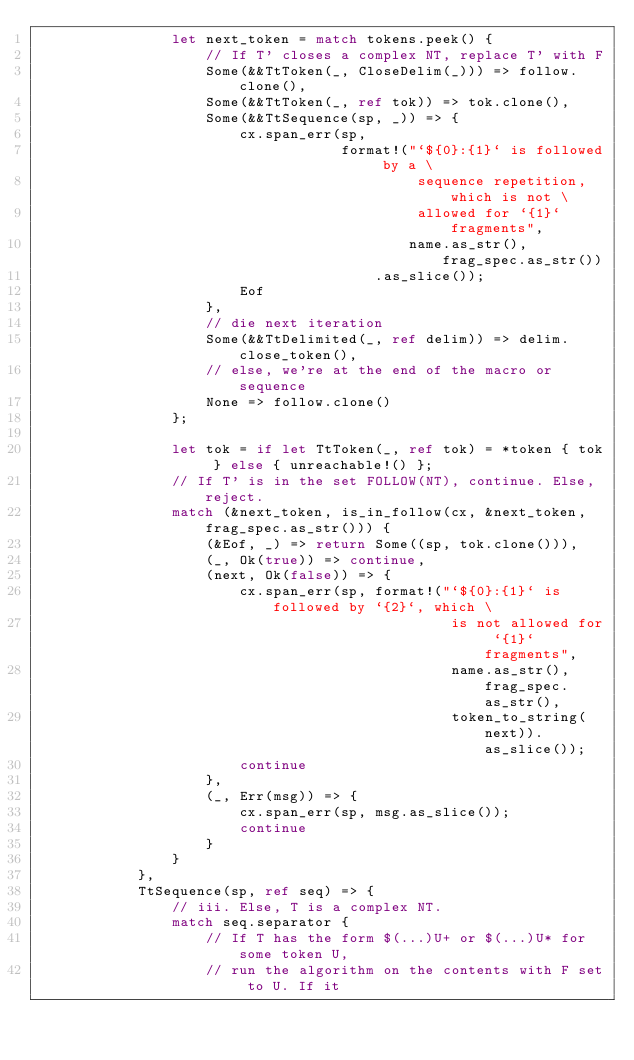Convert code to text. <code><loc_0><loc_0><loc_500><loc_500><_Rust_>                let next_token = match tokens.peek() {
                    // If T' closes a complex NT, replace T' with F
                    Some(&&TtToken(_, CloseDelim(_))) => follow.clone(),
                    Some(&&TtToken(_, ref tok)) => tok.clone(),
                    Some(&&TtSequence(sp, _)) => {
                        cx.span_err(sp,
                                    format!("`${0}:{1}` is followed by a \
                                             sequence repetition, which is not \
                                             allowed for `{1}` fragments",
                                            name.as_str(), frag_spec.as_str())
                                        .as_slice());
                        Eof
                    },
                    // die next iteration
                    Some(&&TtDelimited(_, ref delim)) => delim.close_token(),
                    // else, we're at the end of the macro or sequence
                    None => follow.clone()
                };

                let tok = if let TtToken(_, ref tok) = *token { tok } else { unreachable!() };
                // If T' is in the set FOLLOW(NT), continue. Else, reject.
                match (&next_token, is_in_follow(cx, &next_token, frag_spec.as_str())) {
                    (&Eof, _) => return Some((sp, tok.clone())),
                    (_, Ok(true)) => continue,
                    (next, Ok(false)) => {
                        cx.span_err(sp, format!("`${0}:{1}` is followed by `{2}`, which \
                                                 is not allowed for `{1}` fragments",
                                                 name.as_str(), frag_spec.as_str(),
                                                 token_to_string(next)).as_slice());
                        continue
                    },
                    (_, Err(msg)) => {
                        cx.span_err(sp, msg.as_slice());
                        continue
                    }
                }
            },
            TtSequence(sp, ref seq) => {
                // iii. Else, T is a complex NT.
                match seq.separator {
                    // If T has the form $(...)U+ or $(...)U* for some token U,
                    // run the algorithm on the contents with F set to U. If it</code> 